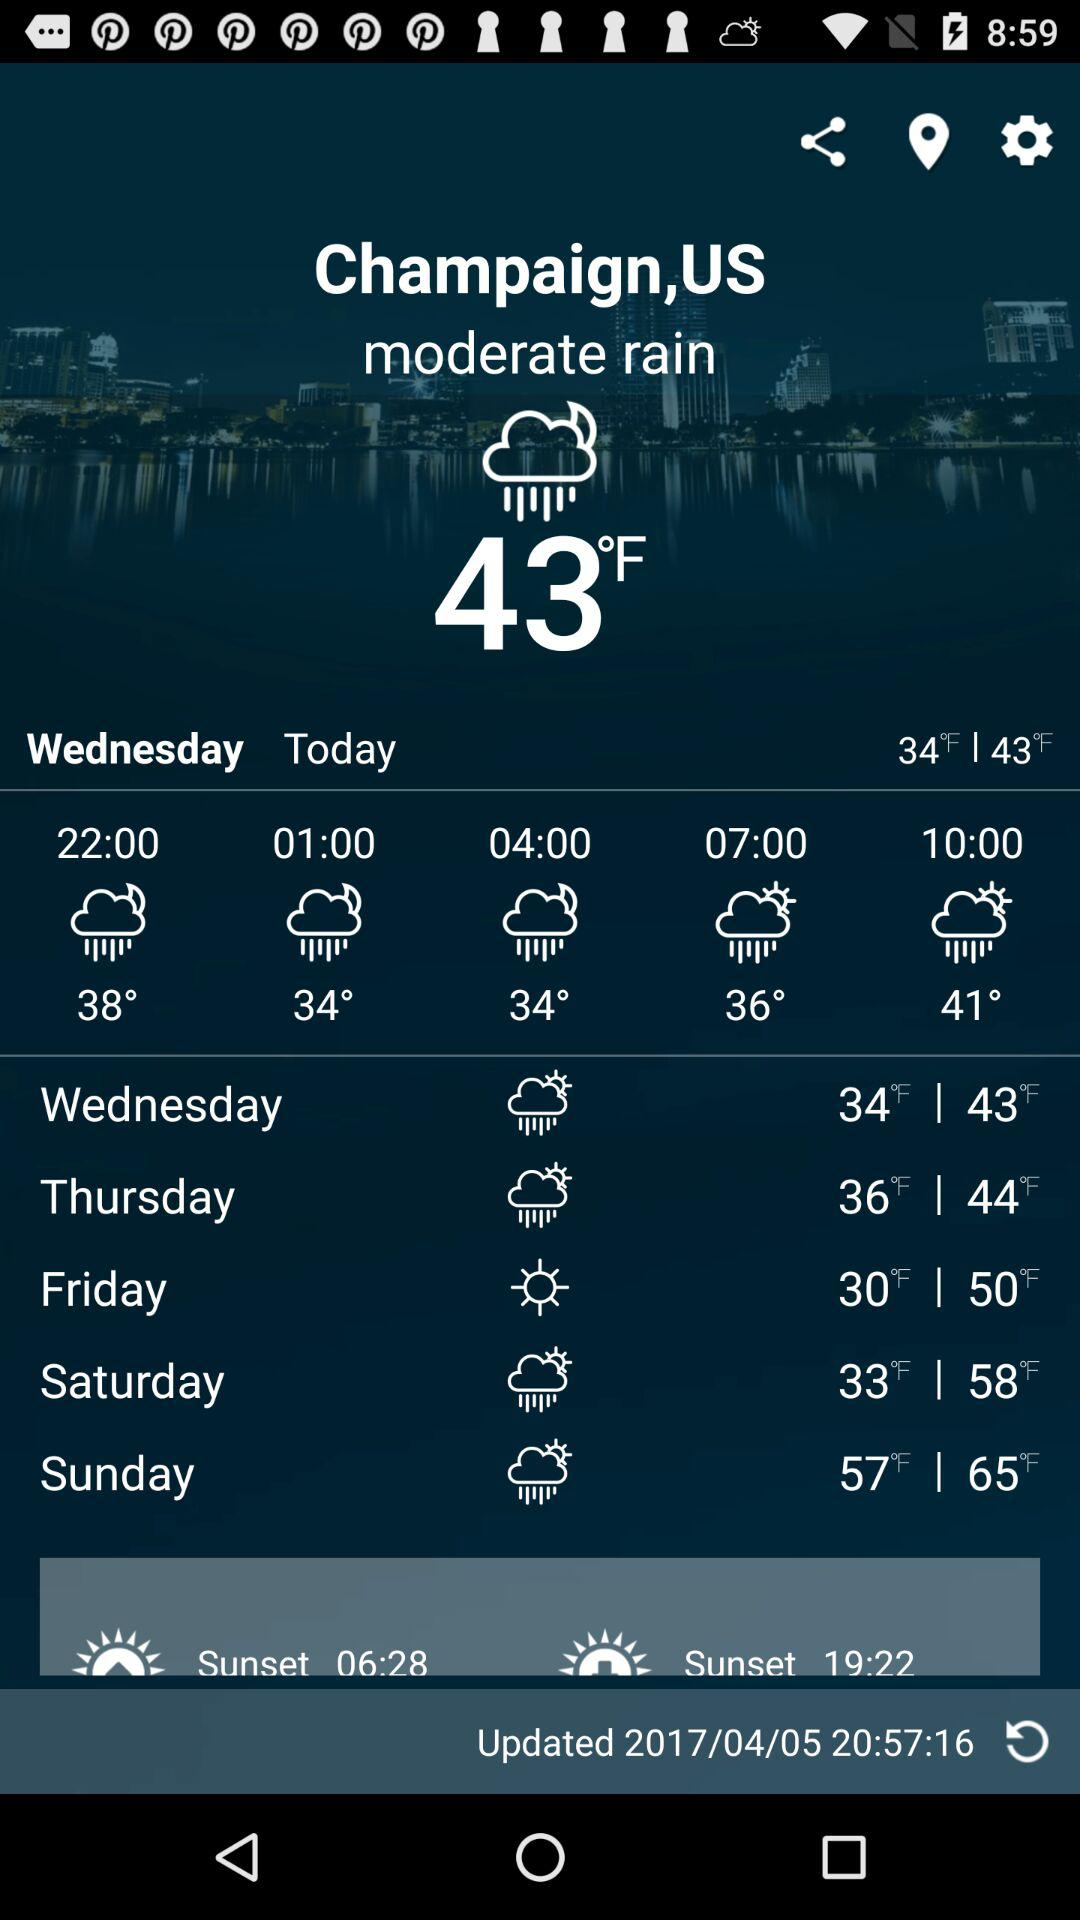What is the updated time? The updated time is 20:57:16. 